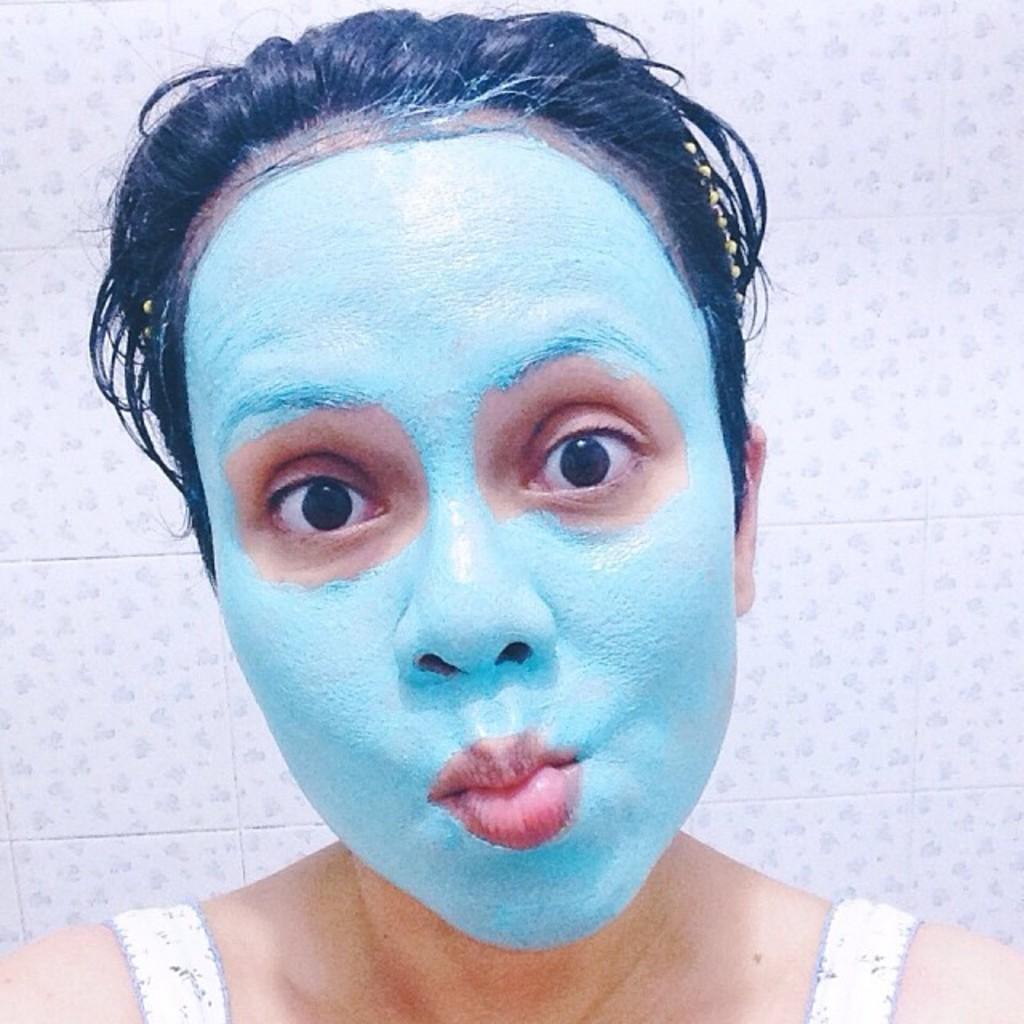In one or two sentences, can you explain what this image depicts? Here we can see a woman with a face pack and looking forward.  